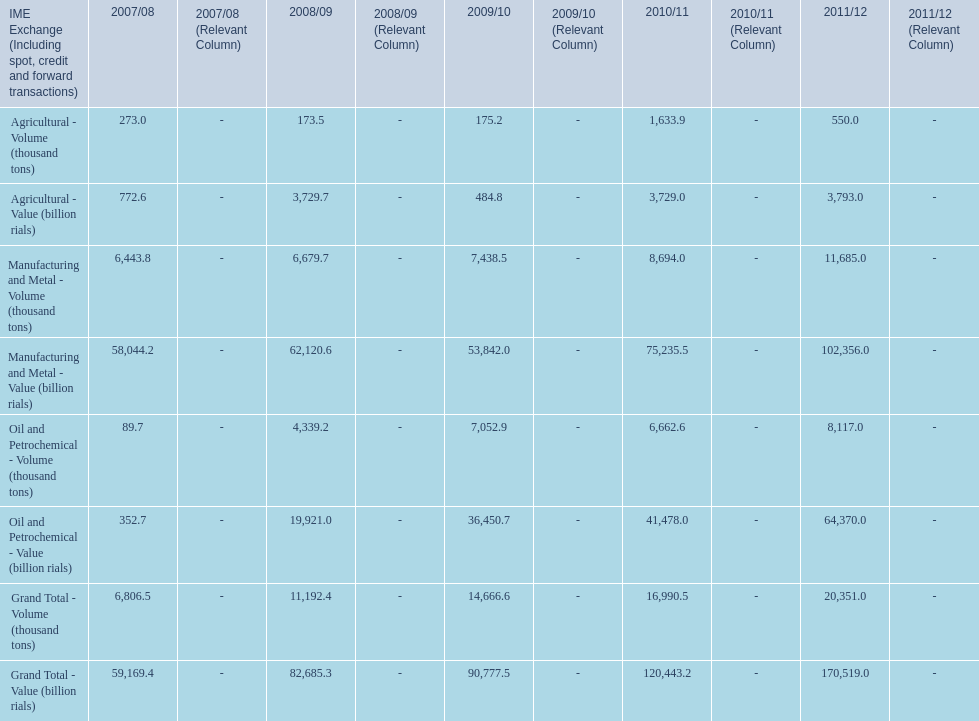How many consecutive year did the grand total value grow in iran? 4. 